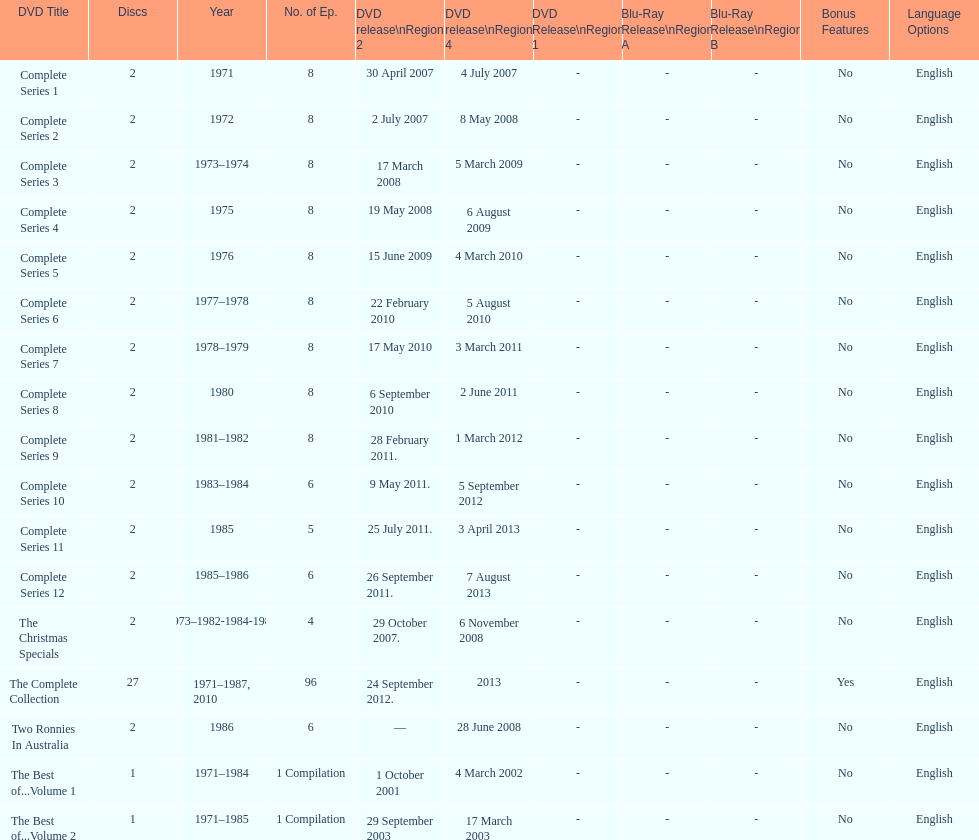What is the count of series featuring 8 episodes? 9. 